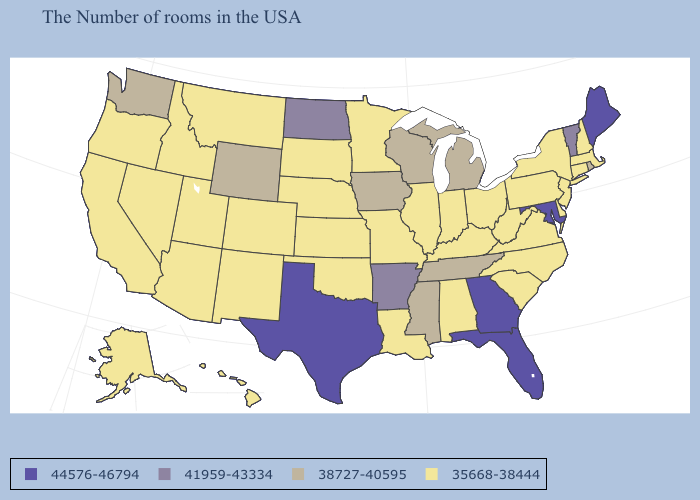What is the lowest value in the Northeast?
Short answer required. 35668-38444. Name the states that have a value in the range 41959-43334?
Answer briefly. Vermont, Arkansas, North Dakota. What is the value of Rhode Island?
Write a very short answer. 38727-40595. Name the states that have a value in the range 41959-43334?
Answer briefly. Vermont, Arkansas, North Dakota. How many symbols are there in the legend?
Be succinct. 4. Which states hav the highest value in the West?
Answer briefly. Wyoming, Washington. How many symbols are there in the legend?
Short answer required. 4. Name the states that have a value in the range 44576-46794?
Quick response, please. Maine, Maryland, Florida, Georgia, Texas. Name the states that have a value in the range 41959-43334?
Concise answer only. Vermont, Arkansas, North Dakota. Among the states that border Indiana , which have the highest value?
Answer briefly. Michigan. Does Maryland have the highest value in the USA?
Write a very short answer. Yes. Does Idaho have a lower value than Iowa?
Write a very short answer. Yes. Does Virginia have the lowest value in the South?
Give a very brief answer. Yes. Among the states that border Utah , which have the lowest value?
Quick response, please. Colorado, New Mexico, Arizona, Idaho, Nevada. What is the lowest value in states that border Oregon?
Write a very short answer. 35668-38444. 